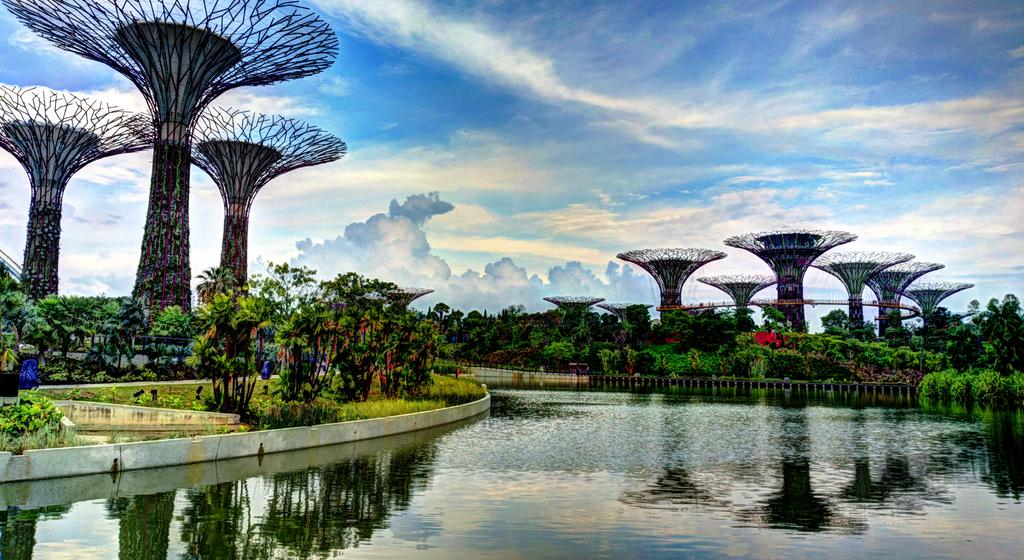What type of natural elements can be seen in the image? There are trees and plants visible in the image. What can be seen in the background of the image? There is water visible in the image. How would you describe the weather in the image? The sky appears to be cloudy in the image. What type of man-made structures are present in the image? There is architecture present in the image. What else can be seen in the image besides the natural elements and architecture? There are objects in the image. What type of baseball story is being told by the trees in the image? There is no baseball story being told by the trees in the image, as there is no reference to baseball or any storytelling elements. 